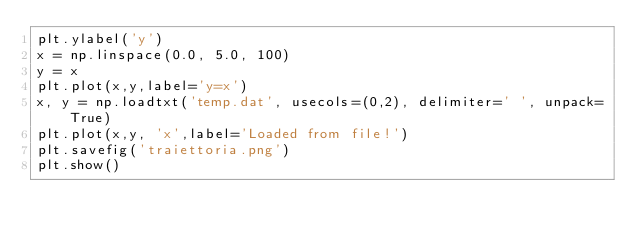<code> <loc_0><loc_0><loc_500><loc_500><_Python_>plt.ylabel('y')
x = np.linspace(0.0, 5.0, 100)
y = x
plt.plot(x,y,label='y=x')
x, y = np.loadtxt('temp.dat', usecols=(0,2), delimiter=' ', unpack=True)
plt.plot(x,y, 'x',label='Loaded from file!')
plt.savefig('traiettoria.png')
plt.show()
</code> 